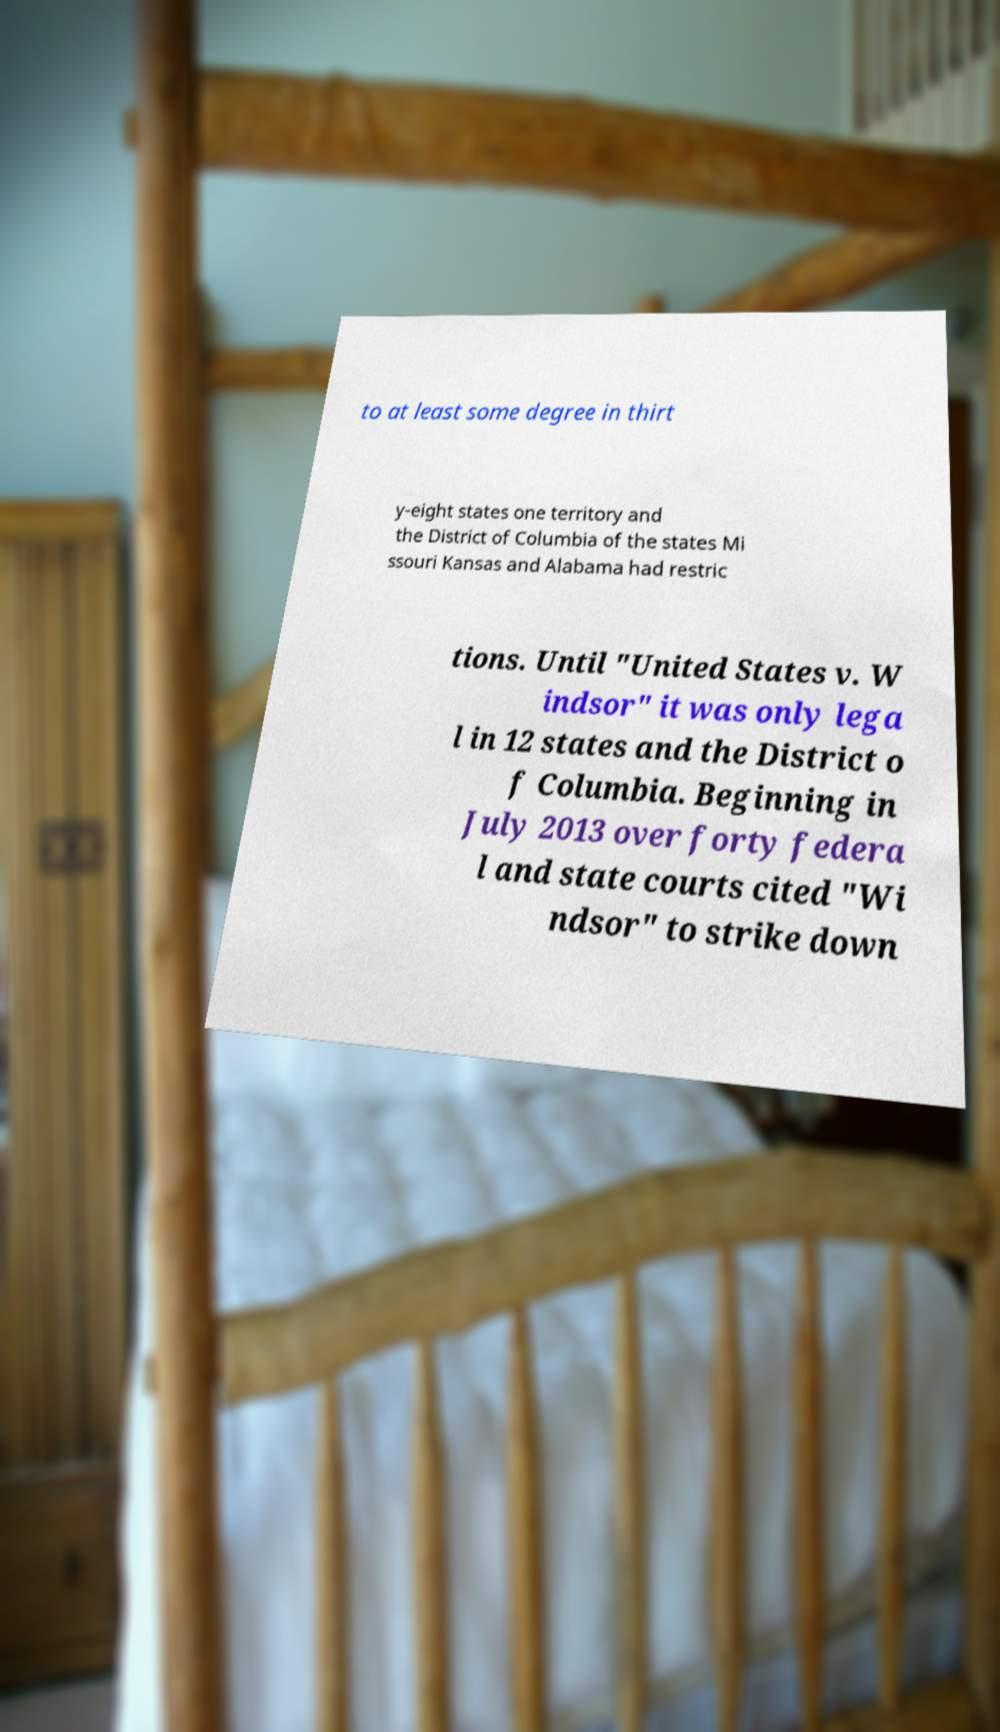Please identify and transcribe the text found in this image. to at least some degree in thirt y-eight states one territory and the District of Columbia of the states Mi ssouri Kansas and Alabama had restric tions. Until "United States v. W indsor" it was only lega l in 12 states and the District o f Columbia. Beginning in July 2013 over forty federa l and state courts cited "Wi ndsor" to strike down 